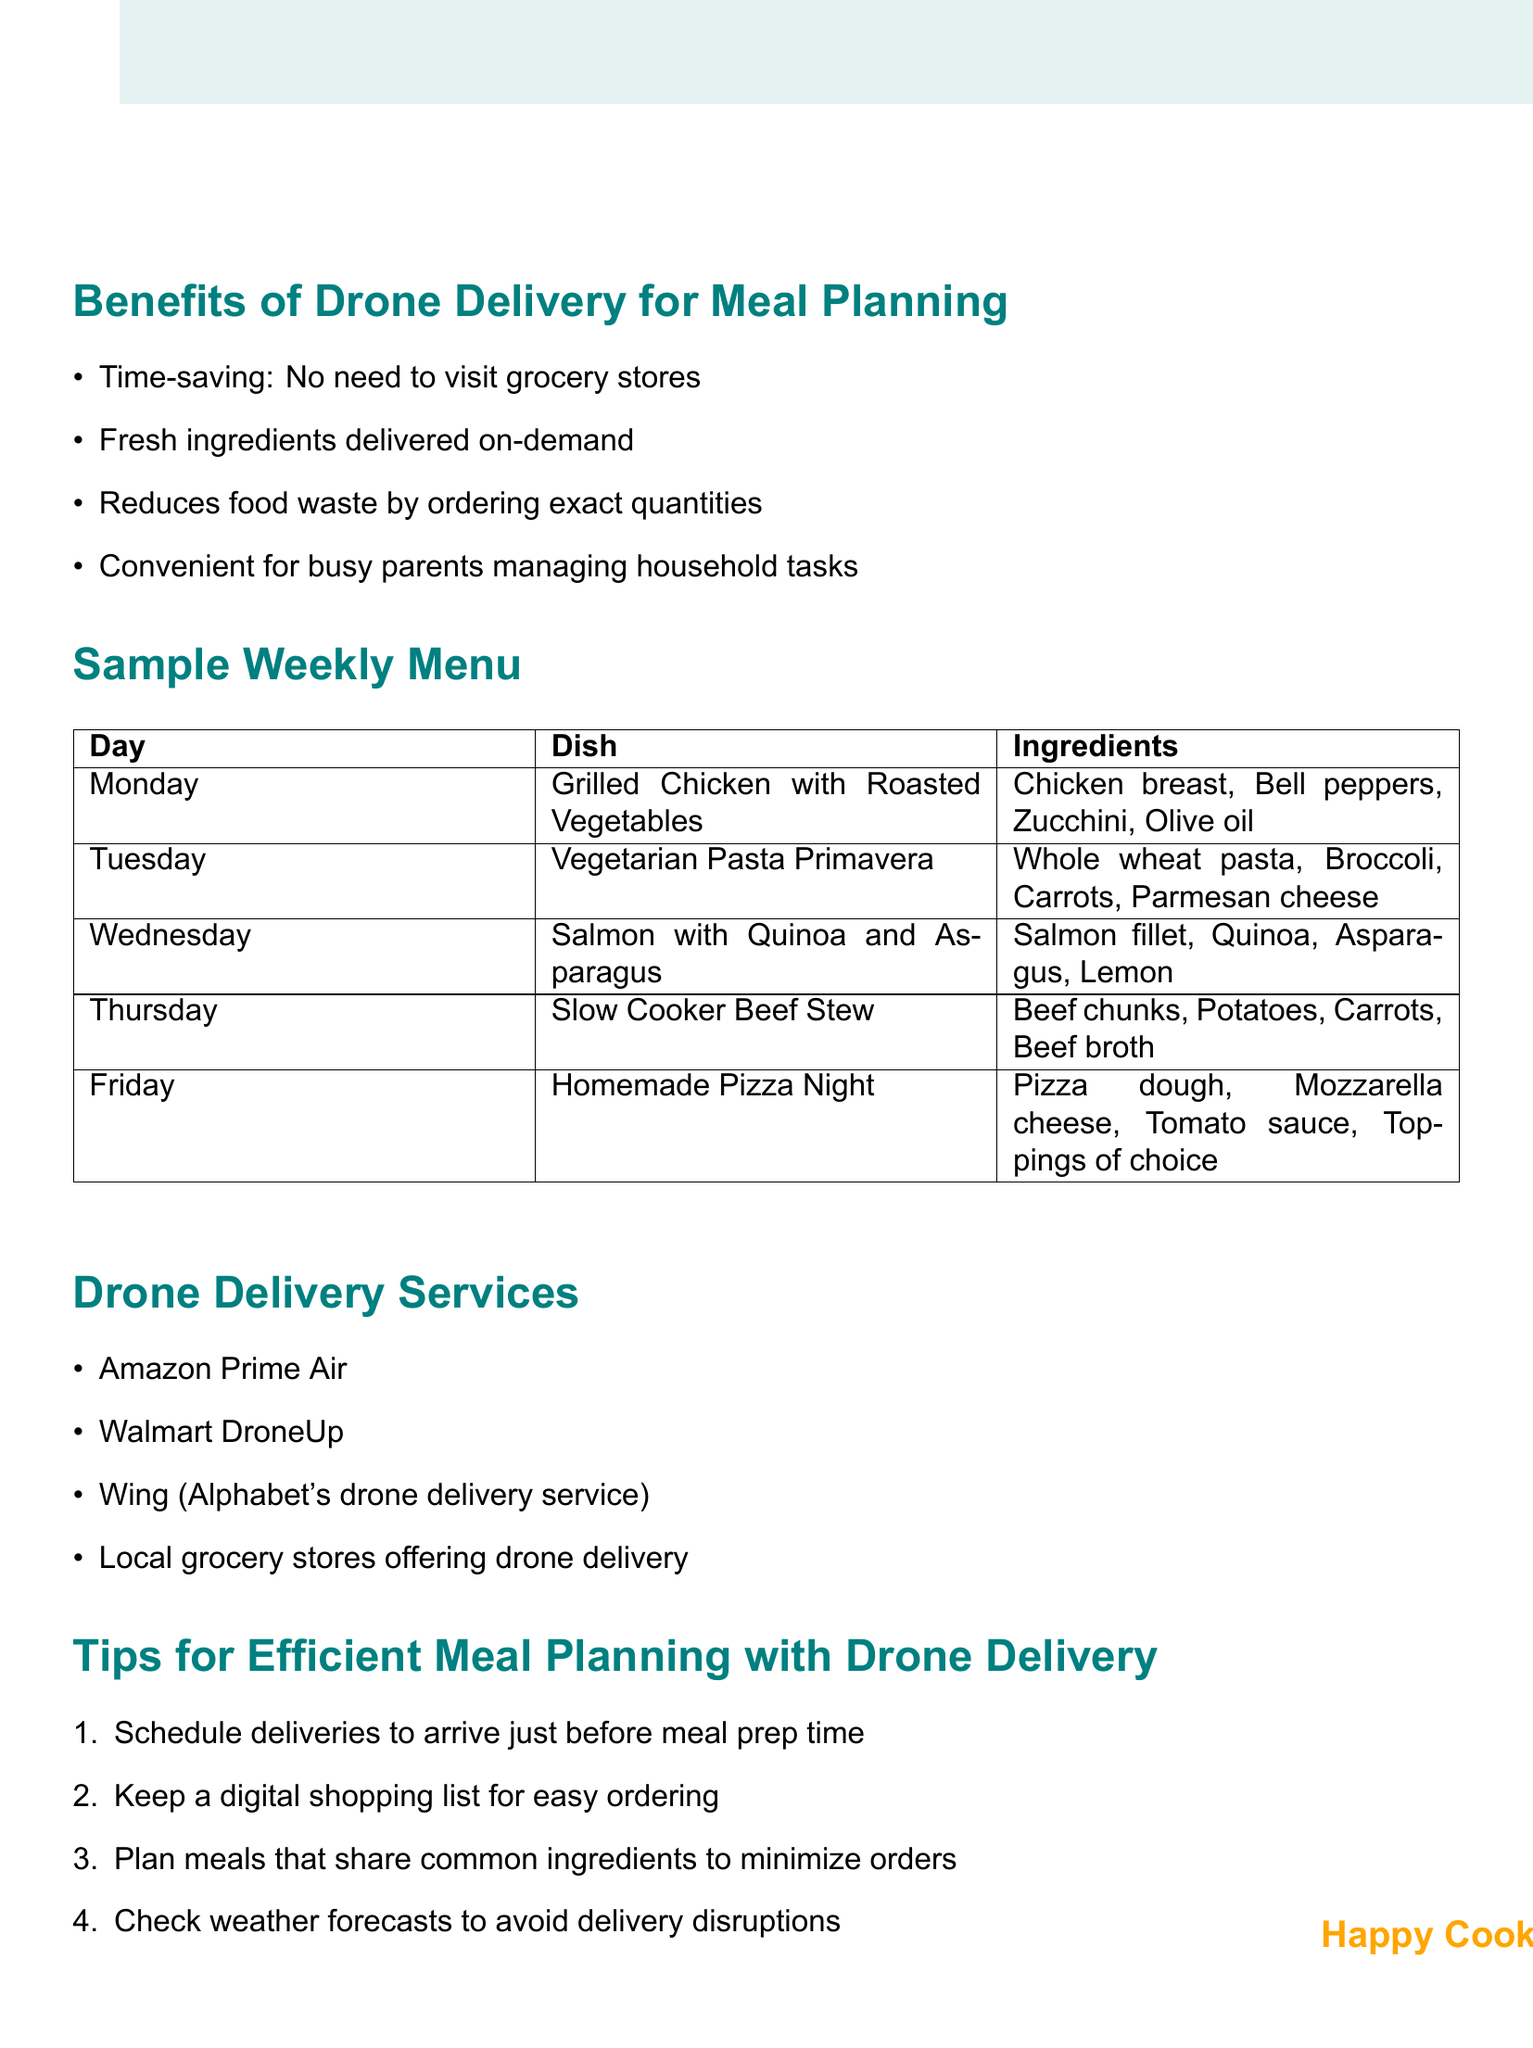What is the dish for Wednesday? The dish for Wednesday is listed under the Sample Weekly Menu section of the document, specifically for that day.
Answer: Salmon with Quinoa and Asparagus Which service is mentioned as a drone delivery provider? The document outlines multiple drone delivery services, and one is specifically named.
Answer: Amazon Prime Air What is one benefit of drone delivery mentioned in the document? The document highlights several benefits of drone delivery, one of which can be identified quickly.
Answer: Time-saving: No need to visit grocery stores How many meals are planned for the week? The weekly menu section provides a list of meals planned for each weekday, making it easy to count them.
Answer: Five What tip is given for scheduling deliveries? The tips section includes various tips for meal planning, including how to effectively schedule deliveries.
Answer: Schedule deliveries to arrive just before meal prep time Which dish includes mozzarella cheese as an ingredient? The document details the dishes and ingredients for the week, allowing for easy identification of the one that includes mozzarella cheese.
Answer: Homemade Pizza Night What type of ingredient is common in the Monday and Tuesday meals? By examining the ingredients listed for both meals, the common type can be inferred.
Answer: Vegetables Which day's dish requires beef chunks? The meals for each day are explicitly listed, making it simple to find the day that requires the specified ingredient.
Answer: Thursday 